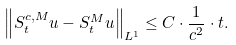Convert formula to latex. <formula><loc_0><loc_0><loc_500><loc_500>\left \| S ^ { c , M } _ { t } u - S ^ { M } _ { t } u \right \| _ { L ^ { 1 } } \leq C \cdot \frac { 1 } { c ^ { 2 } } \cdot t .</formula> 